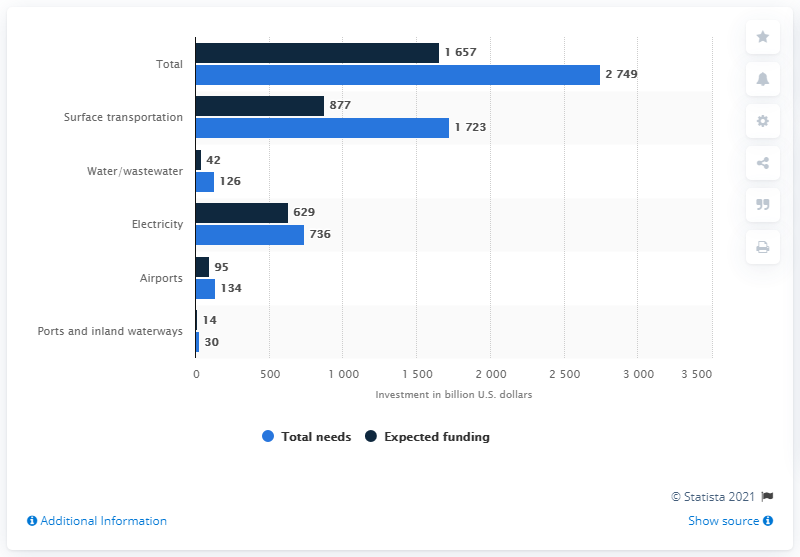List a handful of essential elements in this visual. Between 2010 and 2020, an estimated amount of money is necessary for water or wastewater infrastructure, which is approximately 126. The estimated amount of money that was projected to be spent on infrastructure between 2010 and 2020 was 42. 